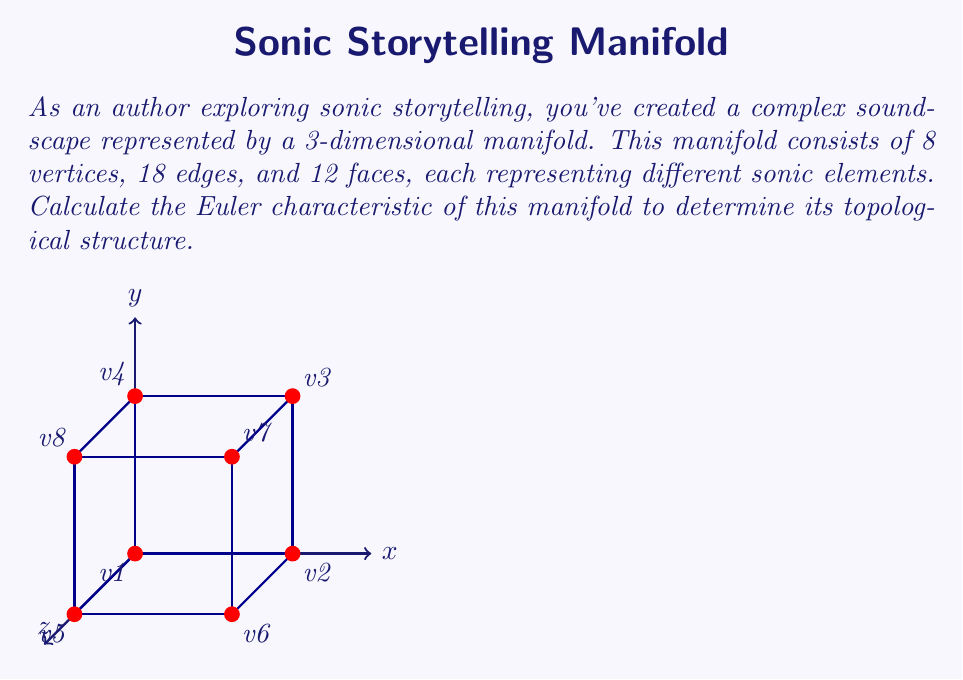Could you help me with this problem? To calculate the Euler characteristic of a manifold, we use the formula:

$$\chi = V - E + F$$

Where:
$\chi$ is the Euler characteristic
$V$ is the number of vertices
$E$ is the number of edges
$F$ is the number of faces

Given:
- Number of vertices (V) = 8
- Number of edges (E) = 18
- Number of faces (F) = 12

Let's substitute these values into the formula:

$$\chi = V - E + F$$
$$\chi = 8 - 18 + 12$$
$$\chi = 2$$

The Euler characteristic of 2 suggests that this manifold is topologically equivalent to a sphere. In the context of sonic storytelling, this could represent a closed, self-contained soundscape with no "holes" or discontinuities in its structure.

This result is consistent with the topological properties of a cube (which is homeomorphic to a sphere), as the diagram suggests. Each vertex in the manifold could represent a key sonic element, edges could represent transitions or relationships between these elements, and faces could represent more complex interactions or layered sounds within the soundscape.
Answer: $\chi = 2$ 